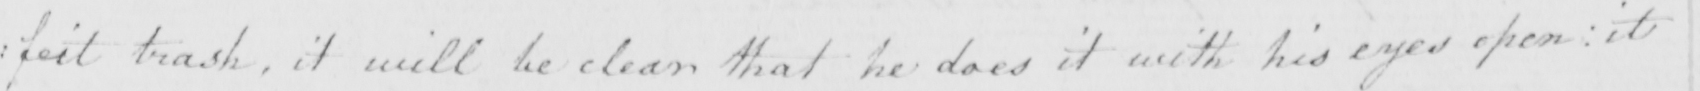Please provide the text content of this handwritten line. : feit trash , it will be clear that he does it with his eyes open :  it 